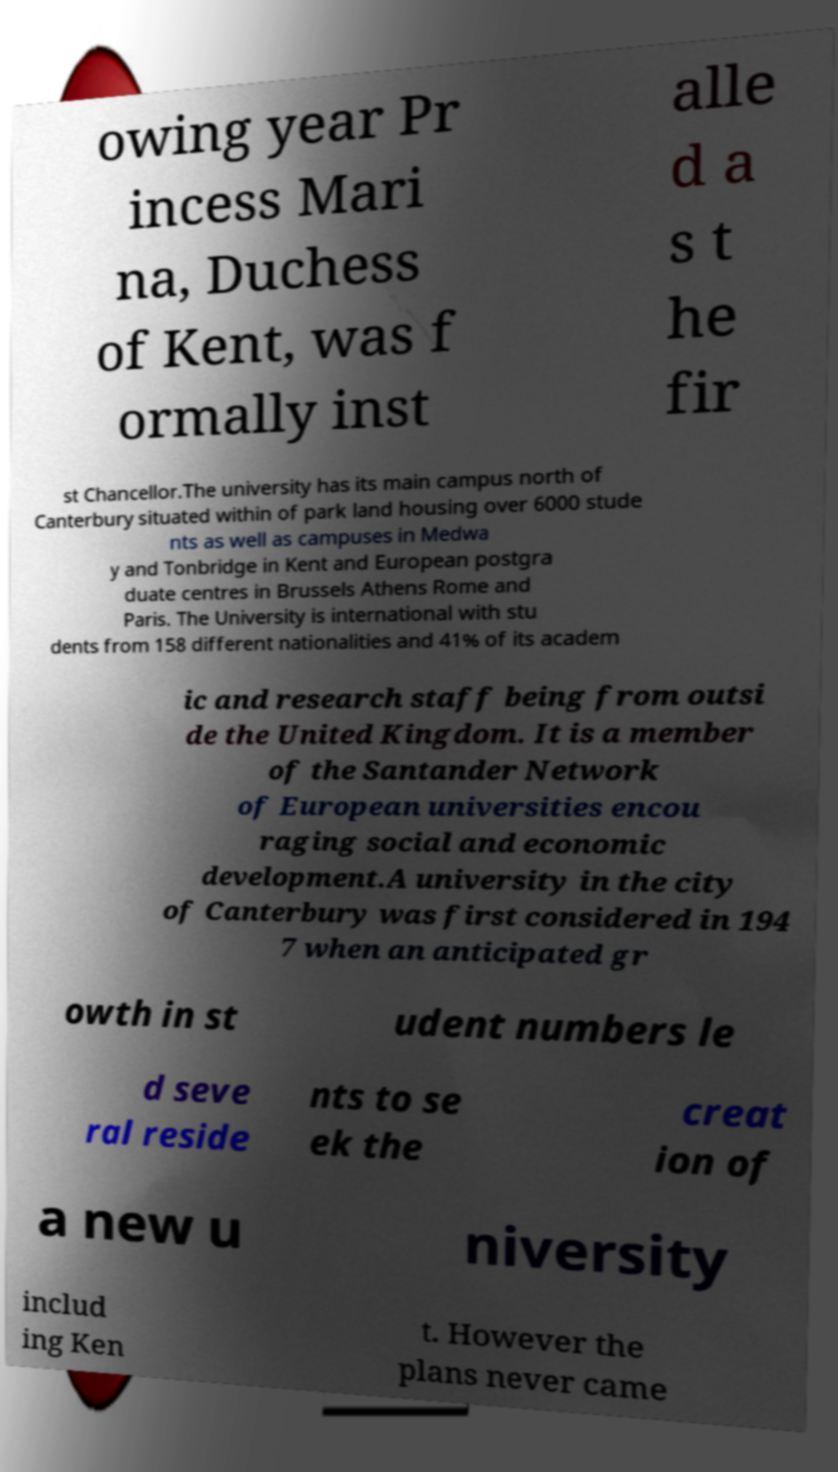There's text embedded in this image that I need extracted. Can you transcribe it verbatim? owing year Pr incess Mari na, Duchess of Kent, was f ormally inst alle d a s t he fir st Chancellor.The university has its main campus north of Canterbury situated within of park land housing over 6000 stude nts as well as campuses in Medwa y and Tonbridge in Kent and European postgra duate centres in Brussels Athens Rome and Paris. The University is international with stu dents from 158 different nationalities and 41% of its academ ic and research staff being from outsi de the United Kingdom. It is a member of the Santander Network of European universities encou raging social and economic development.A university in the city of Canterbury was first considered in 194 7 when an anticipated gr owth in st udent numbers le d seve ral reside nts to se ek the creat ion of a new u niversity includ ing Ken t. However the plans never came 